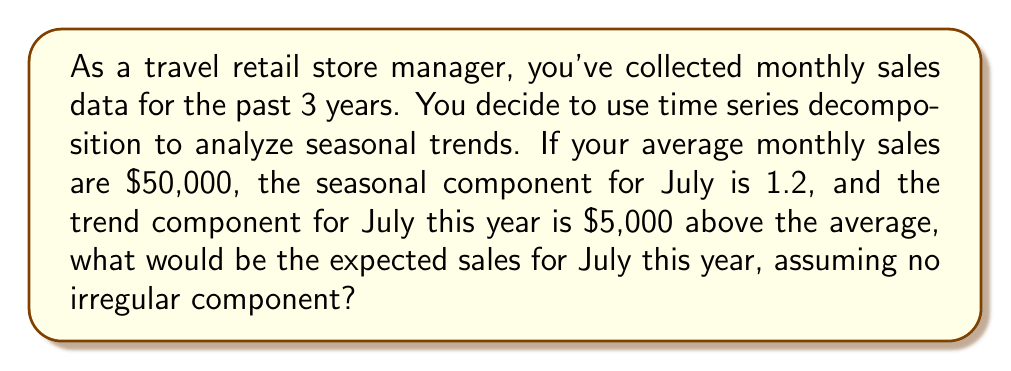Solve this math problem. To solve this problem, we need to understand the components of time series decomposition and how they interact. The additive model for time series decomposition is:

$$ Y_t = T_t + S_t + I_t $$

Where:
$Y_t$ is the observed value
$T_t$ is the trend component
$S_t$ is the seasonal component
$I_t$ is the irregular component

In this case, we're ignoring the irregular component, so our equation becomes:

$$ Y_t = T_t + S_t $$

We're given the following information:
1. Average monthly sales: $50,000
2. Seasonal component for July: 1.2
3. Trend component for July this year: $5,000 above average

To calculate the expected sales:

1. Calculate the trend component ($T_t$):
   $T_t = \text{Average sales} + \text{Trend above average}$
   $T_t = 50,000 + 5,000 = 55,000$

2. Calculate the seasonal component ($S_t$):
   The seasonal component is given as a multiplicative factor. We need to convert it to an additive factor:
   $S_t = \text{Average sales} \times (\text{Seasonal factor} - 1)$
   $S_t = 50,000 \times (1.2 - 1) = 50,000 \times 0.2 = 10,000$

3. Sum the trend and seasonal components:
   $Y_t = T_t + S_t = 55,000 + 10,000 = 65,000$

Therefore, the expected sales for July this year would be $65,000.
Answer: $65,000 